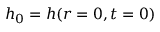<formula> <loc_0><loc_0><loc_500><loc_500>h _ { 0 } = h ( r = 0 , t = 0 )</formula> 